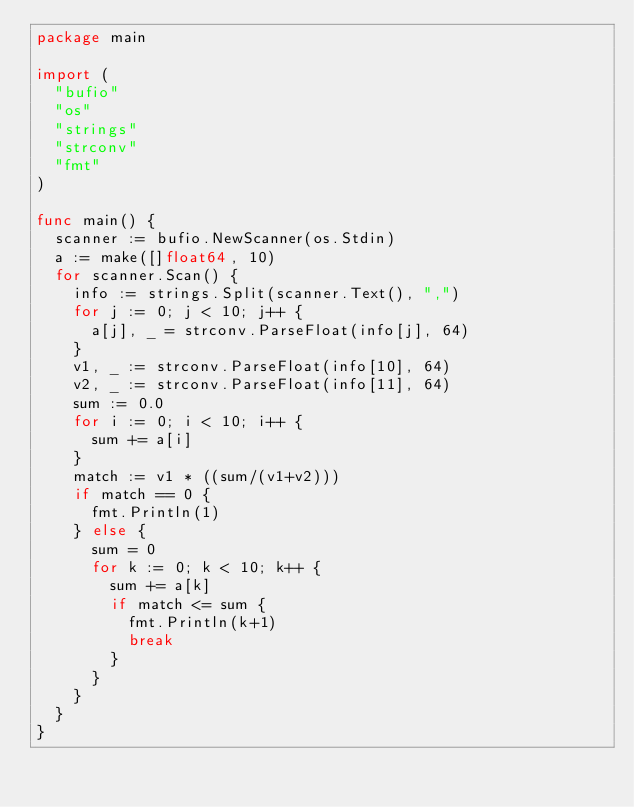Convert code to text. <code><loc_0><loc_0><loc_500><loc_500><_Go_>package main

import (
	"bufio"
	"os"
	"strings"
	"strconv"
	"fmt"
)

func main() {
	scanner := bufio.NewScanner(os.Stdin)
	a := make([]float64, 10)
	for scanner.Scan() {
		info := strings.Split(scanner.Text(), ",")
		for j := 0; j < 10; j++ {
			a[j], _ = strconv.ParseFloat(info[j], 64)
		}
		v1, _ := strconv.ParseFloat(info[10], 64)
		v2, _ := strconv.ParseFloat(info[11], 64)
		sum := 0.0
		for i := 0; i < 10; i++ {
			sum += a[i]
		}
		match := v1 * ((sum/(v1+v2)))
		if match == 0 {
			fmt.Println(1)
		} else {
			sum = 0
			for k := 0; k < 10; k++ {
				sum += a[k]
				if match <= sum {
					fmt.Println(k+1)
					break
				}
			}
		}
	}
}
</code> 